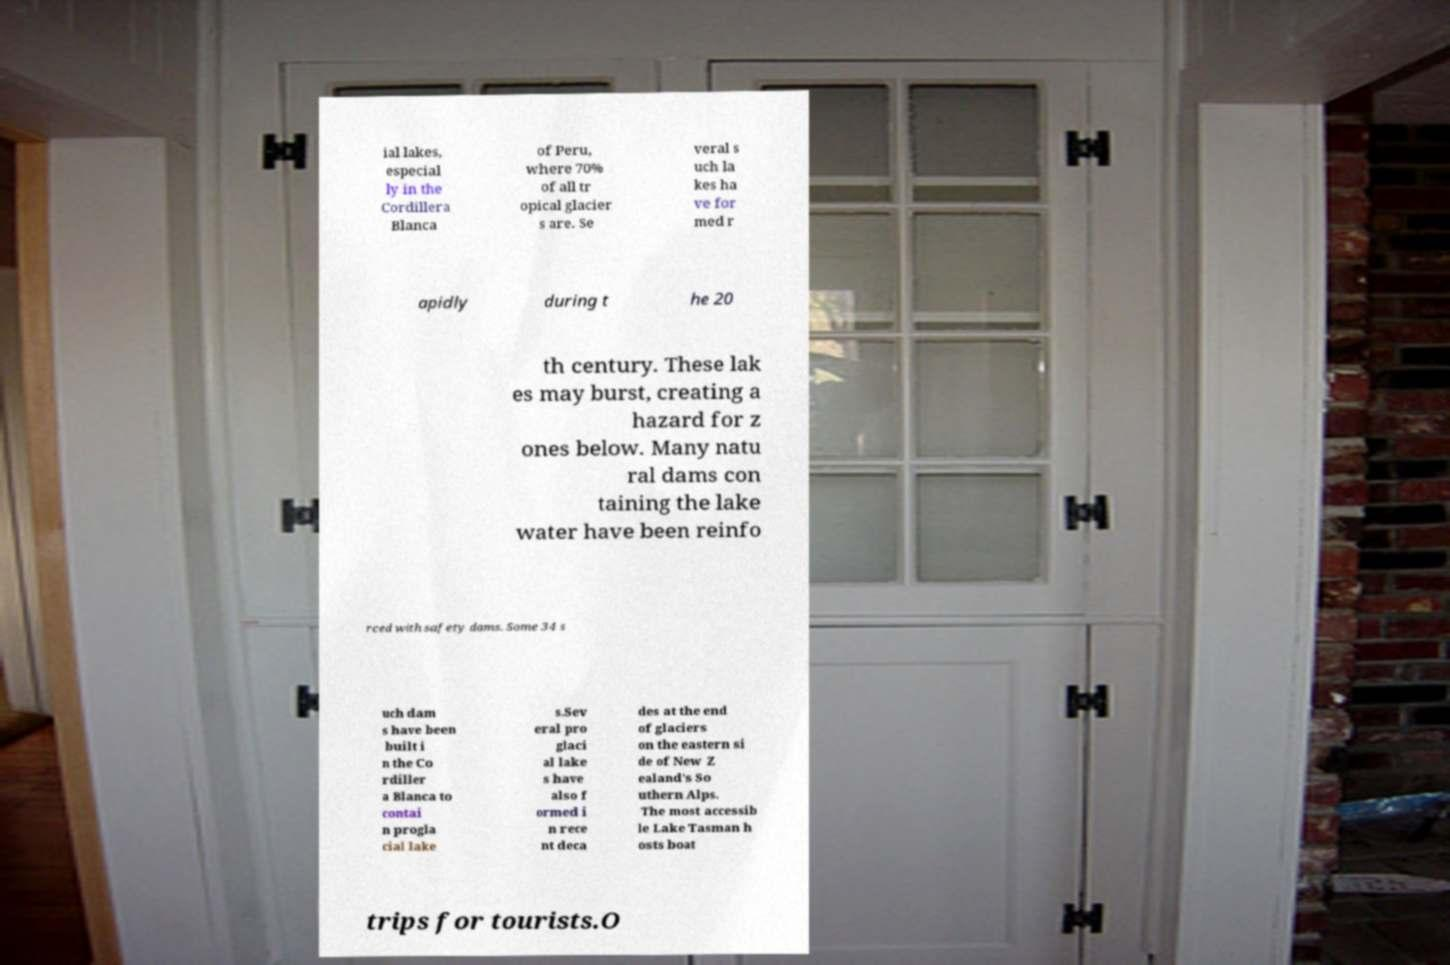Can you read and provide the text displayed in the image?This photo seems to have some interesting text. Can you extract and type it out for me? ial lakes, especial ly in the Cordillera Blanca of Peru, where 70% of all tr opical glacier s are. Se veral s uch la kes ha ve for med r apidly during t he 20 th century. These lak es may burst, creating a hazard for z ones below. Many natu ral dams con taining the lake water have been reinfo rced with safety dams. Some 34 s uch dam s have been built i n the Co rdiller a Blanca to contai n progla cial lake s.Sev eral pro glaci al lake s have also f ormed i n rece nt deca des at the end of glaciers on the eastern si de of New Z ealand's So uthern Alps. The most accessib le Lake Tasman h osts boat trips for tourists.O 